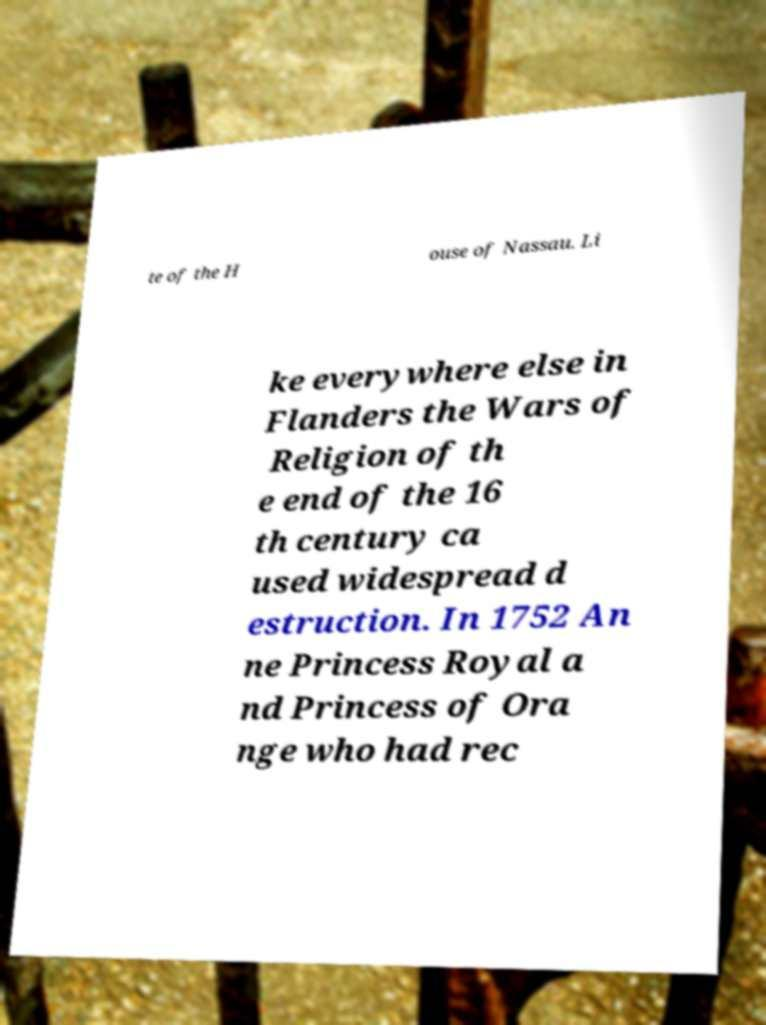Could you assist in decoding the text presented in this image and type it out clearly? te of the H ouse of Nassau. Li ke everywhere else in Flanders the Wars of Religion of th e end of the 16 th century ca used widespread d estruction. In 1752 An ne Princess Royal a nd Princess of Ora nge who had rec 